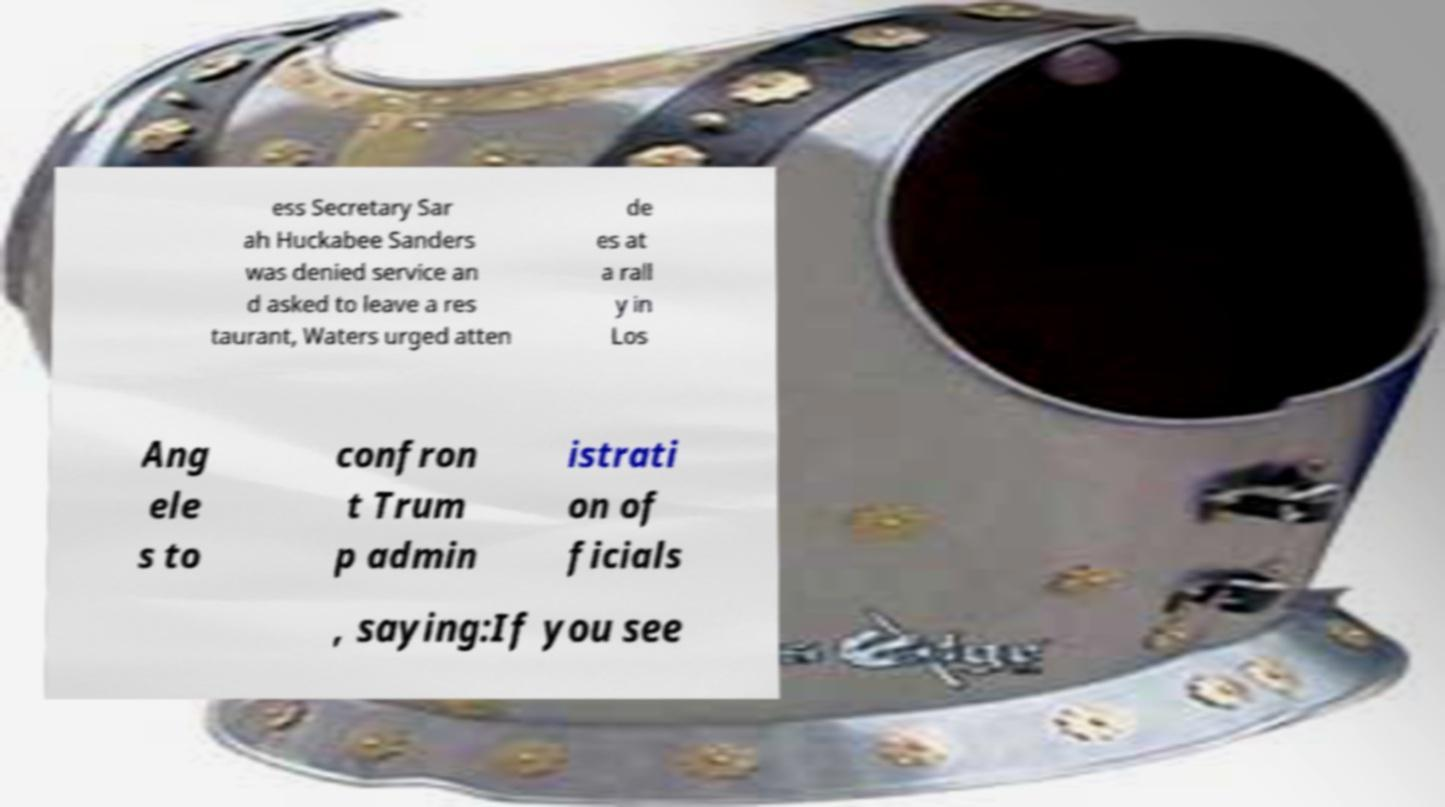For documentation purposes, I need the text within this image transcribed. Could you provide that? ess Secretary Sar ah Huckabee Sanders was denied service an d asked to leave a res taurant, Waters urged atten de es at a rall y in Los Ang ele s to confron t Trum p admin istrati on of ficials , saying:If you see 